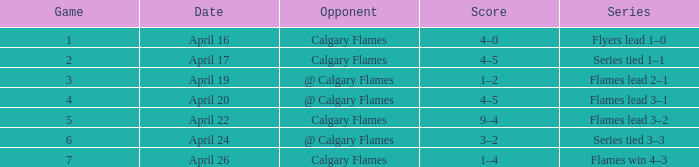Which Series has a Score of 9–4? Flames lead 3–2. 